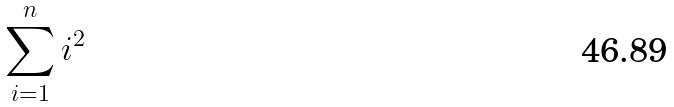<formula> <loc_0><loc_0><loc_500><loc_500>\sum _ { i = 1 } ^ { n } i ^ { 2 }</formula> 